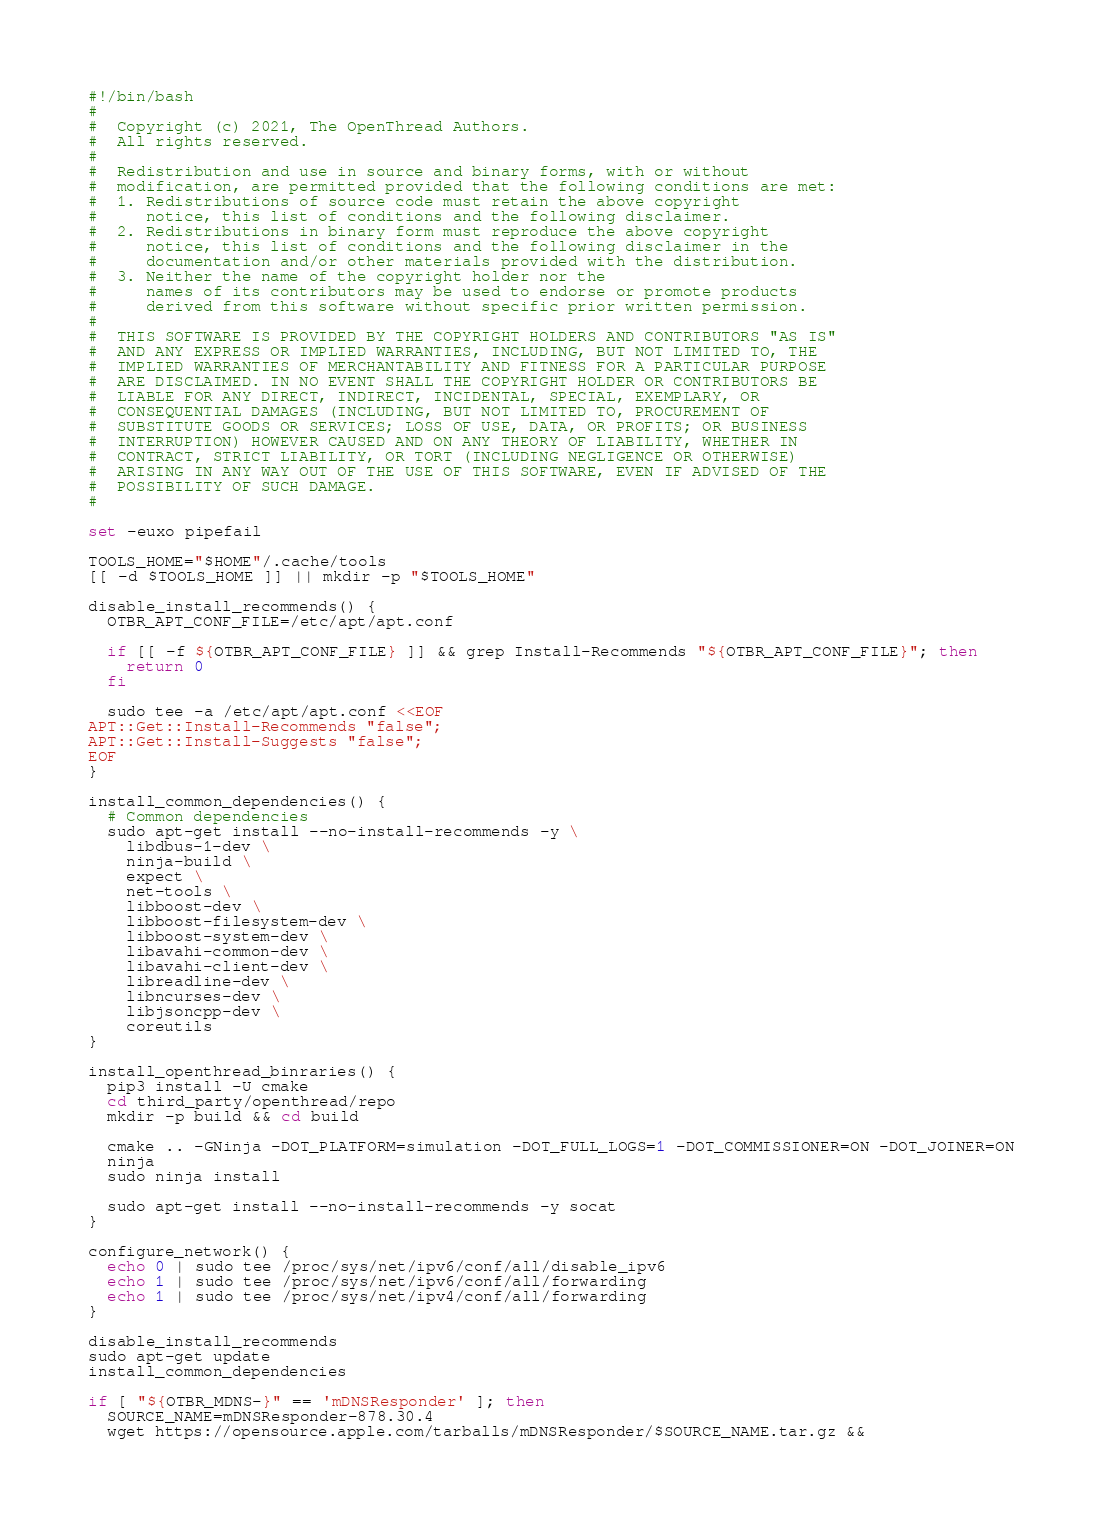Convert code to text. <code><loc_0><loc_0><loc_500><loc_500><_Bash_>#!/bin/bash
#
#  Copyright (c) 2021, The OpenThread Authors.
#  All rights reserved.
#
#  Redistribution and use in source and binary forms, with or without
#  modification, are permitted provided that the following conditions are met:
#  1. Redistributions of source code must retain the above copyright
#     notice, this list of conditions and the following disclaimer.
#  2. Redistributions in binary form must reproduce the above copyright
#     notice, this list of conditions and the following disclaimer in the
#     documentation and/or other materials provided with the distribution.
#  3. Neither the name of the copyright holder nor the
#     names of its contributors may be used to endorse or promote products
#     derived from this software without specific prior written permission.
#
#  THIS SOFTWARE IS PROVIDED BY THE COPYRIGHT HOLDERS AND CONTRIBUTORS "AS IS"
#  AND ANY EXPRESS OR IMPLIED WARRANTIES, INCLUDING, BUT NOT LIMITED TO, THE
#  IMPLIED WARRANTIES OF MERCHANTABILITY AND FITNESS FOR A PARTICULAR PURPOSE
#  ARE DISCLAIMED. IN NO EVENT SHALL THE COPYRIGHT HOLDER OR CONTRIBUTORS BE
#  LIABLE FOR ANY DIRECT, INDIRECT, INCIDENTAL, SPECIAL, EXEMPLARY, OR
#  CONSEQUENTIAL DAMAGES (INCLUDING, BUT NOT LIMITED TO, PROCUREMENT OF
#  SUBSTITUTE GOODS OR SERVICES; LOSS OF USE, DATA, OR PROFITS; OR BUSINESS
#  INTERRUPTION) HOWEVER CAUSED AND ON ANY THEORY OF LIABILITY, WHETHER IN
#  CONTRACT, STRICT LIABILITY, OR TORT (INCLUDING NEGLIGENCE OR OTHERWISE)
#  ARISING IN ANY WAY OUT OF THE USE OF THIS SOFTWARE, EVEN IF ADVISED OF THE
#  POSSIBILITY OF SUCH DAMAGE.
#

set -euxo pipefail

TOOLS_HOME="$HOME"/.cache/tools
[[ -d $TOOLS_HOME ]] || mkdir -p "$TOOLS_HOME"

disable_install_recommends() {
  OTBR_APT_CONF_FILE=/etc/apt/apt.conf

  if [[ -f ${OTBR_APT_CONF_FILE} ]] && grep Install-Recommends "${OTBR_APT_CONF_FILE}"; then
    return 0
  fi

  sudo tee -a /etc/apt/apt.conf <<EOF
APT::Get::Install-Recommends "false";
APT::Get::Install-Suggests "false";
EOF
}

install_common_dependencies() {
  # Common dependencies
  sudo apt-get install --no-install-recommends -y \
    libdbus-1-dev \
    ninja-build \
    expect \
    net-tools \
    libboost-dev \
    libboost-filesystem-dev \
    libboost-system-dev \
    libavahi-common-dev \
    libavahi-client-dev \
    libreadline-dev \
    libncurses-dev \
    libjsoncpp-dev \
    coreutils
}

install_openthread_binraries() {
  pip3 install -U cmake
  cd third_party/openthread/repo
  mkdir -p build && cd build

  cmake .. -GNinja -DOT_PLATFORM=simulation -DOT_FULL_LOGS=1 -DOT_COMMISSIONER=ON -DOT_JOINER=ON
  ninja
  sudo ninja install

  sudo apt-get install --no-install-recommends -y socat
}

configure_network() {
  echo 0 | sudo tee /proc/sys/net/ipv6/conf/all/disable_ipv6
  echo 1 | sudo tee /proc/sys/net/ipv6/conf/all/forwarding
  echo 1 | sudo tee /proc/sys/net/ipv4/conf/all/forwarding
}

disable_install_recommends
sudo apt-get update
install_common_dependencies

if [ "${OTBR_MDNS-}" == 'mDNSResponder' ]; then
  SOURCE_NAME=mDNSResponder-878.30.4
  wget https://opensource.apple.com/tarballs/mDNSResponder/$SOURCE_NAME.tar.gz &&</code> 